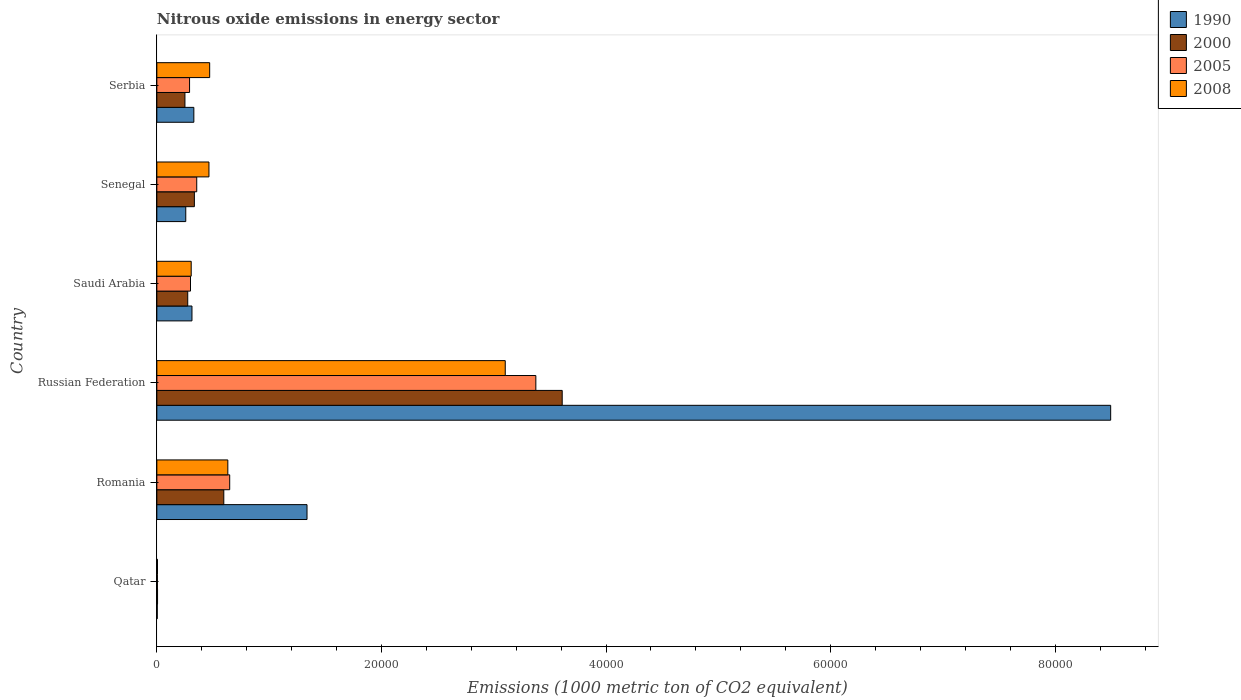How many different coloured bars are there?
Provide a succinct answer. 4. How many groups of bars are there?
Ensure brevity in your answer.  6. Are the number of bars per tick equal to the number of legend labels?
Give a very brief answer. Yes. Are the number of bars on each tick of the Y-axis equal?
Your response must be concise. Yes. How many bars are there on the 4th tick from the bottom?
Make the answer very short. 4. What is the label of the 2nd group of bars from the top?
Your answer should be compact. Senegal. In how many cases, is the number of bars for a given country not equal to the number of legend labels?
Your response must be concise. 0. What is the amount of nitrous oxide emitted in 2000 in Senegal?
Provide a succinct answer. 3341.5. Across all countries, what is the maximum amount of nitrous oxide emitted in 1990?
Keep it short and to the point. 8.49e+04. Across all countries, what is the minimum amount of nitrous oxide emitted in 1990?
Provide a succinct answer. 36. In which country was the amount of nitrous oxide emitted in 2005 maximum?
Keep it short and to the point. Russian Federation. In which country was the amount of nitrous oxide emitted in 2005 minimum?
Your answer should be compact. Qatar. What is the total amount of nitrous oxide emitted in 1990 in the graph?
Provide a succinct answer. 1.07e+05. What is the difference between the amount of nitrous oxide emitted in 2008 in Qatar and that in Romania?
Make the answer very short. -6263.5. What is the difference between the amount of nitrous oxide emitted in 2005 in Serbia and the amount of nitrous oxide emitted in 1990 in Qatar?
Offer a very short reply. 2877.8. What is the average amount of nitrous oxide emitted in 1990 per country?
Your answer should be very brief. 1.79e+04. What is the difference between the amount of nitrous oxide emitted in 2005 and amount of nitrous oxide emitted in 2000 in Romania?
Make the answer very short. 526.1. What is the ratio of the amount of nitrous oxide emitted in 2000 in Qatar to that in Serbia?
Offer a terse response. 0.02. Is the amount of nitrous oxide emitted in 2000 in Qatar less than that in Russian Federation?
Give a very brief answer. Yes. What is the difference between the highest and the second highest amount of nitrous oxide emitted in 2000?
Provide a short and direct response. 3.01e+04. What is the difference between the highest and the lowest amount of nitrous oxide emitted in 2005?
Provide a short and direct response. 3.37e+04. What does the 2nd bar from the top in Romania represents?
Provide a succinct answer. 2005. Is it the case that in every country, the sum of the amount of nitrous oxide emitted in 2000 and amount of nitrous oxide emitted in 2005 is greater than the amount of nitrous oxide emitted in 2008?
Give a very brief answer. Yes. Are all the bars in the graph horizontal?
Keep it short and to the point. Yes. How many countries are there in the graph?
Provide a succinct answer. 6. Are the values on the major ticks of X-axis written in scientific E-notation?
Your answer should be compact. No. Does the graph contain any zero values?
Give a very brief answer. No. Does the graph contain grids?
Keep it short and to the point. No. How are the legend labels stacked?
Offer a terse response. Vertical. What is the title of the graph?
Provide a succinct answer. Nitrous oxide emissions in energy sector. Does "1995" appear as one of the legend labels in the graph?
Offer a terse response. No. What is the label or title of the X-axis?
Provide a short and direct response. Emissions (1000 metric ton of CO2 equivalent). What is the Emissions (1000 metric ton of CO2 equivalent) of 2000 in Qatar?
Provide a short and direct response. 61.6. What is the Emissions (1000 metric ton of CO2 equivalent) in 2005 in Qatar?
Offer a terse response. 49.9. What is the Emissions (1000 metric ton of CO2 equivalent) of 2008 in Qatar?
Provide a short and direct response. 56.6. What is the Emissions (1000 metric ton of CO2 equivalent) of 1990 in Romania?
Keep it short and to the point. 1.34e+04. What is the Emissions (1000 metric ton of CO2 equivalent) of 2000 in Romania?
Provide a succinct answer. 5961.2. What is the Emissions (1000 metric ton of CO2 equivalent) in 2005 in Romania?
Ensure brevity in your answer.  6487.3. What is the Emissions (1000 metric ton of CO2 equivalent) in 2008 in Romania?
Offer a very short reply. 6320.1. What is the Emissions (1000 metric ton of CO2 equivalent) in 1990 in Russian Federation?
Ensure brevity in your answer.  8.49e+04. What is the Emissions (1000 metric ton of CO2 equivalent) of 2000 in Russian Federation?
Offer a terse response. 3.61e+04. What is the Emissions (1000 metric ton of CO2 equivalent) in 2005 in Russian Federation?
Give a very brief answer. 3.37e+04. What is the Emissions (1000 metric ton of CO2 equivalent) in 2008 in Russian Federation?
Your answer should be very brief. 3.10e+04. What is the Emissions (1000 metric ton of CO2 equivalent) of 1990 in Saudi Arabia?
Ensure brevity in your answer.  3126.9. What is the Emissions (1000 metric ton of CO2 equivalent) of 2000 in Saudi Arabia?
Ensure brevity in your answer.  2750.6. What is the Emissions (1000 metric ton of CO2 equivalent) of 2005 in Saudi Arabia?
Offer a very short reply. 2996.3. What is the Emissions (1000 metric ton of CO2 equivalent) of 2008 in Saudi Arabia?
Offer a very short reply. 3059.4. What is the Emissions (1000 metric ton of CO2 equivalent) of 1990 in Senegal?
Your answer should be compact. 2575.1. What is the Emissions (1000 metric ton of CO2 equivalent) in 2000 in Senegal?
Offer a very short reply. 3341.5. What is the Emissions (1000 metric ton of CO2 equivalent) of 2005 in Senegal?
Keep it short and to the point. 3551.3. What is the Emissions (1000 metric ton of CO2 equivalent) of 2008 in Senegal?
Make the answer very short. 4640.3. What is the Emissions (1000 metric ton of CO2 equivalent) in 1990 in Serbia?
Ensure brevity in your answer.  3293.8. What is the Emissions (1000 metric ton of CO2 equivalent) of 2000 in Serbia?
Provide a succinct answer. 2501.4. What is the Emissions (1000 metric ton of CO2 equivalent) in 2005 in Serbia?
Provide a short and direct response. 2913.8. What is the Emissions (1000 metric ton of CO2 equivalent) of 2008 in Serbia?
Ensure brevity in your answer.  4703.6. Across all countries, what is the maximum Emissions (1000 metric ton of CO2 equivalent) in 1990?
Offer a terse response. 8.49e+04. Across all countries, what is the maximum Emissions (1000 metric ton of CO2 equivalent) in 2000?
Provide a succinct answer. 3.61e+04. Across all countries, what is the maximum Emissions (1000 metric ton of CO2 equivalent) of 2005?
Provide a succinct answer. 3.37e+04. Across all countries, what is the maximum Emissions (1000 metric ton of CO2 equivalent) in 2008?
Keep it short and to the point. 3.10e+04. Across all countries, what is the minimum Emissions (1000 metric ton of CO2 equivalent) in 1990?
Make the answer very short. 36. Across all countries, what is the minimum Emissions (1000 metric ton of CO2 equivalent) of 2000?
Your response must be concise. 61.6. Across all countries, what is the minimum Emissions (1000 metric ton of CO2 equivalent) of 2005?
Offer a terse response. 49.9. Across all countries, what is the minimum Emissions (1000 metric ton of CO2 equivalent) of 2008?
Your response must be concise. 56.6. What is the total Emissions (1000 metric ton of CO2 equivalent) in 1990 in the graph?
Make the answer very short. 1.07e+05. What is the total Emissions (1000 metric ton of CO2 equivalent) in 2000 in the graph?
Provide a short and direct response. 5.07e+04. What is the total Emissions (1000 metric ton of CO2 equivalent) in 2005 in the graph?
Your response must be concise. 4.97e+04. What is the total Emissions (1000 metric ton of CO2 equivalent) of 2008 in the graph?
Provide a short and direct response. 4.98e+04. What is the difference between the Emissions (1000 metric ton of CO2 equivalent) in 1990 in Qatar and that in Romania?
Offer a very short reply. -1.33e+04. What is the difference between the Emissions (1000 metric ton of CO2 equivalent) of 2000 in Qatar and that in Romania?
Your answer should be compact. -5899.6. What is the difference between the Emissions (1000 metric ton of CO2 equivalent) in 2005 in Qatar and that in Romania?
Ensure brevity in your answer.  -6437.4. What is the difference between the Emissions (1000 metric ton of CO2 equivalent) in 2008 in Qatar and that in Romania?
Ensure brevity in your answer.  -6263.5. What is the difference between the Emissions (1000 metric ton of CO2 equivalent) of 1990 in Qatar and that in Russian Federation?
Make the answer very short. -8.49e+04. What is the difference between the Emissions (1000 metric ton of CO2 equivalent) in 2000 in Qatar and that in Russian Federation?
Keep it short and to the point. -3.60e+04. What is the difference between the Emissions (1000 metric ton of CO2 equivalent) of 2005 in Qatar and that in Russian Federation?
Give a very brief answer. -3.37e+04. What is the difference between the Emissions (1000 metric ton of CO2 equivalent) in 2008 in Qatar and that in Russian Federation?
Provide a succinct answer. -3.10e+04. What is the difference between the Emissions (1000 metric ton of CO2 equivalent) in 1990 in Qatar and that in Saudi Arabia?
Your answer should be compact. -3090.9. What is the difference between the Emissions (1000 metric ton of CO2 equivalent) in 2000 in Qatar and that in Saudi Arabia?
Offer a very short reply. -2689. What is the difference between the Emissions (1000 metric ton of CO2 equivalent) of 2005 in Qatar and that in Saudi Arabia?
Give a very brief answer. -2946.4. What is the difference between the Emissions (1000 metric ton of CO2 equivalent) in 2008 in Qatar and that in Saudi Arabia?
Provide a succinct answer. -3002.8. What is the difference between the Emissions (1000 metric ton of CO2 equivalent) of 1990 in Qatar and that in Senegal?
Keep it short and to the point. -2539.1. What is the difference between the Emissions (1000 metric ton of CO2 equivalent) of 2000 in Qatar and that in Senegal?
Provide a short and direct response. -3279.9. What is the difference between the Emissions (1000 metric ton of CO2 equivalent) in 2005 in Qatar and that in Senegal?
Give a very brief answer. -3501.4. What is the difference between the Emissions (1000 metric ton of CO2 equivalent) of 2008 in Qatar and that in Senegal?
Your response must be concise. -4583.7. What is the difference between the Emissions (1000 metric ton of CO2 equivalent) in 1990 in Qatar and that in Serbia?
Provide a succinct answer. -3257.8. What is the difference between the Emissions (1000 metric ton of CO2 equivalent) of 2000 in Qatar and that in Serbia?
Your answer should be compact. -2439.8. What is the difference between the Emissions (1000 metric ton of CO2 equivalent) of 2005 in Qatar and that in Serbia?
Your answer should be very brief. -2863.9. What is the difference between the Emissions (1000 metric ton of CO2 equivalent) in 2008 in Qatar and that in Serbia?
Your answer should be compact. -4647. What is the difference between the Emissions (1000 metric ton of CO2 equivalent) of 1990 in Romania and that in Russian Federation?
Give a very brief answer. -7.16e+04. What is the difference between the Emissions (1000 metric ton of CO2 equivalent) in 2000 in Romania and that in Russian Federation?
Your answer should be very brief. -3.01e+04. What is the difference between the Emissions (1000 metric ton of CO2 equivalent) in 2005 in Romania and that in Russian Federation?
Provide a short and direct response. -2.73e+04. What is the difference between the Emissions (1000 metric ton of CO2 equivalent) of 2008 in Romania and that in Russian Federation?
Your answer should be very brief. -2.47e+04. What is the difference between the Emissions (1000 metric ton of CO2 equivalent) of 1990 in Romania and that in Saudi Arabia?
Offer a terse response. 1.02e+04. What is the difference between the Emissions (1000 metric ton of CO2 equivalent) of 2000 in Romania and that in Saudi Arabia?
Make the answer very short. 3210.6. What is the difference between the Emissions (1000 metric ton of CO2 equivalent) in 2005 in Romania and that in Saudi Arabia?
Ensure brevity in your answer.  3491. What is the difference between the Emissions (1000 metric ton of CO2 equivalent) of 2008 in Romania and that in Saudi Arabia?
Make the answer very short. 3260.7. What is the difference between the Emissions (1000 metric ton of CO2 equivalent) in 1990 in Romania and that in Senegal?
Offer a terse response. 1.08e+04. What is the difference between the Emissions (1000 metric ton of CO2 equivalent) of 2000 in Romania and that in Senegal?
Offer a terse response. 2619.7. What is the difference between the Emissions (1000 metric ton of CO2 equivalent) in 2005 in Romania and that in Senegal?
Keep it short and to the point. 2936. What is the difference between the Emissions (1000 metric ton of CO2 equivalent) in 2008 in Romania and that in Senegal?
Provide a short and direct response. 1679.8. What is the difference between the Emissions (1000 metric ton of CO2 equivalent) of 1990 in Romania and that in Serbia?
Offer a very short reply. 1.01e+04. What is the difference between the Emissions (1000 metric ton of CO2 equivalent) of 2000 in Romania and that in Serbia?
Keep it short and to the point. 3459.8. What is the difference between the Emissions (1000 metric ton of CO2 equivalent) in 2005 in Romania and that in Serbia?
Provide a short and direct response. 3573.5. What is the difference between the Emissions (1000 metric ton of CO2 equivalent) in 2008 in Romania and that in Serbia?
Provide a succinct answer. 1616.5. What is the difference between the Emissions (1000 metric ton of CO2 equivalent) in 1990 in Russian Federation and that in Saudi Arabia?
Give a very brief answer. 8.18e+04. What is the difference between the Emissions (1000 metric ton of CO2 equivalent) of 2000 in Russian Federation and that in Saudi Arabia?
Provide a short and direct response. 3.33e+04. What is the difference between the Emissions (1000 metric ton of CO2 equivalent) of 2005 in Russian Federation and that in Saudi Arabia?
Provide a short and direct response. 3.08e+04. What is the difference between the Emissions (1000 metric ton of CO2 equivalent) in 2008 in Russian Federation and that in Saudi Arabia?
Offer a very short reply. 2.80e+04. What is the difference between the Emissions (1000 metric ton of CO2 equivalent) in 1990 in Russian Federation and that in Senegal?
Provide a short and direct response. 8.24e+04. What is the difference between the Emissions (1000 metric ton of CO2 equivalent) in 2000 in Russian Federation and that in Senegal?
Give a very brief answer. 3.28e+04. What is the difference between the Emissions (1000 metric ton of CO2 equivalent) of 2005 in Russian Federation and that in Senegal?
Your answer should be compact. 3.02e+04. What is the difference between the Emissions (1000 metric ton of CO2 equivalent) in 2008 in Russian Federation and that in Senegal?
Give a very brief answer. 2.64e+04. What is the difference between the Emissions (1000 metric ton of CO2 equivalent) of 1990 in Russian Federation and that in Serbia?
Your response must be concise. 8.16e+04. What is the difference between the Emissions (1000 metric ton of CO2 equivalent) in 2000 in Russian Federation and that in Serbia?
Ensure brevity in your answer.  3.36e+04. What is the difference between the Emissions (1000 metric ton of CO2 equivalent) of 2005 in Russian Federation and that in Serbia?
Ensure brevity in your answer.  3.08e+04. What is the difference between the Emissions (1000 metric ton of CO2 equivalent) of 2008 in Russian Federation and that in Serbia?
Keep it short and to the point. 2.63e+04. What is the difference between the Emissions (1000 metric ton of CO2 equivalent) in 1990 in Saudi Arabia and that in Senegal?
Keep it short and to the point. 551.8. What is the difference between the Emissions (1000 metric ton of CO2 equivalent) of 2000 in Saudi Arabia and that in Senegal?
Give a very brief answer. -590.9. What is the difference between the Emissions (1000 metric ton of CO2 equivalent) of 2005 in Saudi Arabia and that in Senegal?
Offer a very short reply. -555. What is the difference between the Emissions (1000 metric ton of CO2 equivalent) of 2008 in Saudi Arabia and that in Senegal?
Give a very brief answer. -1580.9. What is the difference between the Emissions (1000 metric ton of CO2 equivalent) in 1990 in Saudi Arabia and that in Serbia?
Your answer should be compact. -166.9. What is the difference between the Emissions (1000 metric ton of CO2 equivalent) of 2000 in Saudi Arabia and that in Serbia?
Provide a short and direct response. 249.2. What is the difference between the Emissions (1000 metric ton of CO2 equivalent) in 2005 in Saudi Arabia and that in Serbia?
Your response must be concise. 82.5. What is the difference between the Emissions (1000 metric ton of CO2 equivalent) of 2008 in Saudi Arabia and that in Serbia?
Give a very brief answer. -1644.2. What is the difference between the Emissions (1000 metric ton of CO2 equivalent) in 1990 in Senegal and that in Serbia?
Ensure brevity in your answer.  -718.7. What is the difference between the Emissions (1000 metric ton of CO2 equivalent) of 2000 in Senegal and that in Serbia?
Offer a terse response. 840.1. What is the difference between the Emissions (1000 metric ton of CO2 equivalent) of 2005 in Senegal and that in Serbia?
Give a very brief answer. 637.5. What is the difference between the Emissions (1000 metric ton of CO2 equivalent) in 2008 in Senegal and that in Serbia?
Your answer should be very brief. -63.3. What is the difference between the Emissions (1000 metric ton of CO2 equivalent) in 1990 in Qatar and the Emissions (1000 metric ton of CO2 equivalent) in 2000 in Romania?
Your answer should be compact. -5925.2. What is the difference between the Emissions (1000 metric ton of CO2 equivalent) in 1990 in Qatar and the Emissions (1000 metric ton of CO2 equivalent) in 2005 in Romania?
Ensure brevity in your answer.  -6451.3. What is the difference between the Emissions (1000 metric ton of CO2 equivalent) of 1990 in Qatar and the Emissions (1000 metric ton of CO2 equivalent) of 2008 in Romania?
Offer a terse response. -6284.1. What is the difference between the Emissions (1000 metric ton of CO2 equivalent) in 2000 in Qatar and the Emissions (1000 metric ton of CO2 equivalent) in 2005 in Romania?
Your response must be concise. -6425.7. What is the difference between the Emissions (1000 metric ton of CO2 equivalent) in 2000 in Qatar and the Emissions (1000 metric ton of CO2 equivalent) in 2008 in Romania?
Keep it short and to the point. -6258.5. What is the difference between the Emissions (1000 metric ton of CO2 equivalent) of 2005 in Qatar and the Emissions (1000 metric ton of CO2 equivalent) of 2008 in Romania?
Ensure brevity in your answer.  -6270.2. What is the difference between the Emissions (1000 metric ton of CO2 equivalent) in 1990 in Qatar and the Emissions (1000 metric ton of CO2 equivalent) in 2000 in Russian Federation?
Offer a very short reply. -3.61e+04. What is the difference between the Emissions (1000 metric ton of CO2 equivalent) of 1990 in Qatar and the Emissions (1000 metric ton of CO2 equivalent) of 2005 in Russian Federation?
Give a very brief answer. -3.37e+04. What is the difference between the Emissions (1000 metric ton of CO2 equivalent) of 1990 in Qatar and the Emissions (1000 metric ton of CO2 equivalent) of 2008 in Russian Federation?
Keep it short and to the point. -3.10e+04. What is the difference between the Emissions (1000 metric ton of CO2 equivalent) of 2000 in Qatar and the Emissions (1000 metric ton of CO2 equivalent) of 2005 in Russian Federation?
Offer a very short reply. -3.37e+04. What is the difference between the Emissions (1000 metric ton of CO2 equivalent) in 2000 in Qatar and the Emissions (1000 metric ton of CO2 equivalent) in 2008 in Russian Federation?
Provide a succinct answer. -3.10e+04. What is the difference between the Emissions (1000 metric ton of CO2 equivalent) of 2005 in Qatar and the Emissions (1000 metric ton of CO2 equivalent) of 2008 in Russian Federation?
Make the answer very short. -3.10e+04. What is the difference between the Emissions (1000 metric ton of CO2 equivalent) of 1990 in Qatar and the Emissions (1000 metric ton of CO2 equivalent) of 2000 in Saudi Arabia?
Your response must be concise. -2714.6. What is the difference between the Emissions (1000 metric ton of CO2 equivalent) in 1990 in Qatar and the Emissions (1000 metric ton of CO2 equivalent) in 2005 in Saudi Arabia?
Provide a short and direct response. -2960.3. What is the difference between the Emissions (1000 metric ton of CO2 equivalent) of 1990 in Qatar and the Emissions (1000 metric ton of CO2 equivalent) of 2008 in Saudi Arabia?
Offer a terse response. -3023.4. What is the difference between the Emissions (1000 metric ton of CO2 equivalent) in 2000 in Qatar and the Emissions (1000 metric ton of CO2 equivalent) in 2005 in Saudi Arabia?
Your answer should be very brief. -2934.7. What is the difference between the Emissions (1000 metric ton of CO2 equivalent) in 2000 in Qatar and the Emissions (1000 metric ton of CO2 equivalent) in 2008 in Saudi Arabia?
Give a very brief answer. -2997.8. What is the difference between the Emissions (1000 metric ton of CO2 equivalent) of 2005 in Qatar and the Emissions (1000 metric ton of CO2 equivalent) of 2008 in Saudi Arabia?
Your answer should be compact. -3009.5. What is the difference between the Emissions (1000 metric ton of CO2 equivalent) in 1990 in Qatar and the Emissions (1000 metric ton of CO2 equivalent) in 2000 in Senegal?
Keep it short and to the point. -3305.5. What is the difference between the Emissions (1000 metric ton of CO2 equivalent) of 1990 in Qatar and the Emissions (1000 metric ton of CO2 equivalent) of 2005 in Senegal?
Make the answer very short. -3515.3. What is the difference between the Emissions (1000 metric ton of CO2 equivalent) in 1990 in Qatar and the Emissions (1000 metric ton of CO2 equivalent) in 2008 in Senegal?
Your answer should be compact. -4604.3. What is the difference between the Emissions (1000 metric ton of CO2 equivalent) of 2000 in Qatar and the Emissions (1000 metric ton of CO2 equivalent) of 2005 in Senegal?
Your answer should be compact. -3489.7. What is the difference between the Emissions (1000 metric ton of CO2 equivalent) in 2000 in Qatar and the Emissions (1000 metric ton of CO2 equivalent) in 2008 in Senegal?
Your answer should be compact. -4578.7. What is the difference between the Emissions (1000 metric ton of CO2 equivalent) in 2005 in Qatar and the Emissions (1000 metric ton of CO2 equivalent) in 2008 in Senegal?
Your response must be concise. -4590.4. What is the difference between the Emissions (1000 metric ton of CO2 equivalent) of 1990 in Qatar and the Emissions (1000 metric ton of CO2 equivalent) of 2000 in Serbia?
Ensure brevity in your answer.  -2465.4. What is the difference between the Emissions (1000 metric ton of CO2 equivalent) of 1990 in Qatar and the Emissions (1000 metric ton of CO2 equivalent) of 2005 in Serbia?
Keep it short and to the point. -2877.8. What is the difference between the Emissions (1000 metric ton of CO2 equivalent) of 1990 in Qatar and the Emissions (1000 metric ton of CO2 equivalent) of 2008 in Serbia?
Give a very brief answer. -4667.6. What is the difference between the Emissions (1000 metric ton of CO2 equivalent) of 2000 in Qatar and the Emissions (1000 metric ton of CO2 equivalent) of 2005 in Serbia?
Your answer should be very brief. -2852.2. What is the difference between the Emissions (1000 metric ton of CO2 equivalent) in 2000 in Qatar and the Emissions (1000 metric ton of CO2 equivalent) in 2008 in Serbia?
Provide a succinct answer. -4642. What is the difference between the Emissions (1000 metric ton of CO2 equivalent) of 2005 in Qatar and the Emissions (1000 metric ton of CO2 equivalent) of 2008 in Serbia?
Your answer should be very brief. -4653.7. What is the difference between the Emissions (1000 metric ton of CO2 equivalent) in 1990 in Romania and the Emissions (1000 metric ton of CO2 equivalent) in 2000 in Russian Federation?
Provide a short and direct response. -2.27e+04. What is the difference between the Emissions (1000 metric ton of CO2 equivalent) in 1990 in Romania and the Emissions (1000 metric ton of CO2 equivalent) in 2005 in Russian Federation?
Offer a very short reply. -2.04e+04. What is the difference between the Emissions (1000 metric ton of CO2 equivalent) in 1990 in Romania and the Emissions (1000 metric ton of CO2 equivalent) in 2008 in Russian Federation?
Offer a very short reply. -1.77e+04. What is the difference between the Emissions (1000 metric ton of CO2 equivalent) of 2000 in Romania and the Emissions (1000 metric ton of CO2 equivalent) of 2005 in Russian Federation?
Offer a terse response. -2.78e+04. What is the difference between the Emissions (1000 metric ton of CO2 equivalent) in 2000 in Romania and the Emissions (1000 metric ton of CO2 equivalent) in 2008 in Russian Federation?
Ensure brevity in your answer.  -2.51e+04. What is the difference between the Emissions (1000 metric ton of CO2 equivalent) in 2005 in Romania and the Emissions (1000 metric ton of CO2 equivalent) in 2008 in Russian Federation?
Your answer should be very brief. -2.45e+04. What is the difference between the Emissions (1000 metric ton of CO2 equivalent) of 1990 in Romania and the Emissions (1000 metric ton of CO2 equivalent) of 2000 in Saudi Arabia?
Make the answer very short. 1.06e+04. What is the difference between the Emissions (1000 metric ton of CO2 equivalent) of 1990 in Romania and the Emissions (1000 metric ton of CO2 equivalent) of 2005 in Saudi Arabia?
Your response must be concise. 1.04e+04. What is the difference between the Emissions (1000 metric ton of CO2 equivalent) in 1990 in Romania and the Emissions (1000 metric ton of CO2 equivalent) in 2008 in Saudi Arabia?
Offer a very short reply. 1.03e+04. What is the difference between the Emissions (1000 metric ton of CO2 equivalent) of 2000 in Romania and the Emissions (1000 metric ton of CO2 equivalent) of 2005 in Saudi Arabia?
Offer a very short reply. 2964.9. What is the difference between the Emissions (1000 metric ton of CO2 equivalent) of 2000 in Romania and the Emissions (1000 metric ton of CO2 equivalent) of 2008 in Saudi Arabia?
Provide a short and direct response. 2901.8. What is the difference between the Emissions (1000 metric ton of CO2 equivalent) of 2005 in Romania and the Emissions (1000 metric ton of CO2 equivalent) of 2008 in Saudi Arabia?
Ensure brevity in your answer.  3427.9. What is the difference between the Emissions (1000 metric ton of CO2 equivalent) in 1990 in Romania and the Emissions (1000 metric ton of CO2 equivalent) in 2000 in Senegal?
Your answer should be very brief. 1.00e+04. What is the difference between the Emissions (1000 metric ton of CO2 equivalent) in 1990 in Romania and the Emissions (1000 metric ton of CO2 equivalent) in 2005 in Senegal?
Your answer should be compact. 9821. What is the difference between the Emissions (1000 metric ton of CO2 equivalent) of 1990 in Romania and the Emissions (1000 metric ton of CO2 equivalent) of 2008 in Senegal?
Give a very brief answer. 8732. What is the difference between the Emissions (1000 metric ton of CO2 equivalent) in 2000 in Romania and the Emissions (1000 metric ton of CO2 equivalent) in 2005 in Senegal?
Offer a terse response. 2409.9. What is the difference between the Emissions (1000 metric ton of CO2 equivalent) in 2000 in Romania and the Emissions (1000 metric ton of CO2 equivalent) in 2008 in Senegal?
Provide a succinct answer. 1320.9. What is the difference between the Emissions (1000 metric ton of CO2 equivalent) in 2005 in Romania and the Emissions (1000 metric ton of CO2 equivalent) in 2008 in Senegal?
Keep it short and to the point. 1847. What is the difference between the Emissions (1000 metric ton of CO2 equivalent) of 1990 in Romania and the Emissions (1000 metric ton of CO2 equivalent) of 2000 in Serbia?
Ensure brevity in your answer.  1.09e+04. What is the difference between the Emissions (1000 metric ton of CO2 equivalent) in 1990 in Romania and the Emissions (1000 metric ton of CO2 equivalent) in 2005 in Serbia?
Keep it short and to the point. 1.05e+04. What is the difference between the Emissions (1000 metric ton of CO2 equivalent) of 1990 in Romania and the Emissions (1000 metric ton of CO2 equivalent) of 2008 in Serbia?
Offer a very short reply. 8668.7. What is the difference between the Emissions (1000 metric ton of CO2 equivalent) in 2000 in Romania and the Emissions (1000 metric ton of CO2 equivalent) in 2005 in Serbia?
Offer a terse response. 3047.4. What is the difference between the Emissions (1000 metric ton of CO2 equivalent) in 2000 in Romania and the Emissions (1000 metric ton of CO2 equivalent) in 2008 in Serbia?
Provide a succinct answer. 1257.6. What is the difference between the Emissions (1000 metric ton of CO2 equivalent) of 2005 in Romania and the Emissions (1000 metric ton of CO2 equivalent) of 2008 in Serbia?
Offer a very short reply. 1783.7. What is the difference between the Emissions (1000 metric ton of CO2 equivalent) of 1990 in Russian Federation and the Emissions (1000 metric ton of CO2 equivalent) of 2000 in Saudi Arabia?
Offer a terse response. 8.22e+04. What is the difference between the Emissions (1000 metric ton of CO2 equivalent) of 1990 in Russian Federation and the Emissions (1000 metric ton of CO2 equivalent) of 2005 in Saudi Arabia?
Offer a very short reply. 8.19e+04. What is the difference between the Emissions (1000 metric ton of CO2 equivalent) of 1990 in Russian Federation and the Emissions (1000 metric ton of CO2 equivalent) of 2008 in Saudi Arabia?
Offer a very short reply. 8.19e+04. What is the difference between the Emissions (1000 metric ton of CO2 equivalent) in 2000 in Russian Federation and the Emissions (1000 metric ton of CO2 equivalent) in 2005 in Saudi Arabia?
Ensure brevity in your answer.  3.31e+04. What is the difference between the Emissions (1000 metric ton of CO2 equivalent) of 2000 in Russian Federation and the Emissions (1000 metric ton of CO2 equivalent) of 2008 in Saudi Arabia?
Your answer should be compact. 3.30e+04. What is the difference between the Emissions (1000 metric ton of CO2 equivalent) of 2005 in Russian Federation and the Emissions (1000 metric ton of CO2 equivalent) of 2008 in Saudi Arabia?
Offer a terse response. 3.07e+04. What is the difference between the Emissions (1000 metric ton of CO2 equivalent) of 1990 in Russian Federation and the Emissions (1000 metric ton of CO2 equivalent) of 2000 in Senegal?
Offer a very short reply. 8.16e+04. What is the difference between the Emissions (1000 metric ton of CO2 equivalent) in 1990 in Russian Federation and the Emissions (1000 metric ton of CO2 equivalent) in 2005 in Senegal?
Provide a succinct answer. 8.14e+04. What is the difference between the Emissions (1000 metric ton of CO2 equivalent) of 1990 in Russian Federation and the Emissions (1000 metric ton of CO2 equivalent) of 2008 in Senegal?
Offer a very short reply. 8.03e+04. What is the difference between the Emissions (1000 metric ton of CO2 equivalent) in 2000 in Russian Federation and the Emissions (1000 metric ton of CO2 equivalent) in 2005 in Senegal?
Make the answer very short. 3.25e+04. What is the difference between the Emissions (1000 metric ton of CO2 equivalent) in 2000 in Russian Federation and the Emissions (1000 metric ton of CO2 equivalent) in 2008 in Senegal?
Keep it short and to the point. 3.15e+04. What is the difference between the Emissions (1000 metric ton of CO2 equivalent) of 2005 in Russian Federation and the Emissions (1000 metric ton of CO2 equivalent) of 2008 in Senegal?
Give a very brief answer. 2.91e+04. What is the difference between the Emissions (1000 metric ton of CO2 equivalent) of 1990 in Russian Federation and the Emissions (1000 metric ton of CO2 equivalent) of 2000 in Serbia?
Keep it short and to the point. 8.24e+04. What is the difference between the Emissions (1000 metric ton of CO2 equivalent) in 1990 in Russian Federation and the Emissions (1000 metric ton of CO2 equivalent) in 2005 in Serbia?
Provide a succinct answer. 8.20e+04. What is the difference between the Emissions (1000 metric ton of CO2 equivalent) in 1990 in Russian Federation and the Emissions (1000 metric ton of CO2 equivalent) in 2008 in Serbia?
Offer a very short reply. 8.02e+04. What is the difference between the Emissions (1000 metric ton of CO2 equivalent) of 2000 in Russian Federation and the Emissions (1000 metric ton of CO2 equivalent) of 2005 in Serbia?
Keep it short and to the point. 3.32e+04. What is the difference between the Emissions (1000 metric ton of CO2 equivalent) in 2000 in Russian Federation and the Emissions (1000 metric ton of CO2 equivalent) in 2008 in Serbia?
Make the answer very short. 3.14e+04. What is the difference between the Emissions (1000 metric ton of CO2 equivalent) in 2005 in Russian Federation and the Emissions (1000 metric ton of CO2 equivalent) in 2008 in Serbia?
Provide a succinct answer. 2.90e+04. What is the difference between the Emissions (1000 metric ton of CO2 equivalent) of 1990 in Saudi Arabia and the Emissions (1000 metric ton of CO2 equivalent) of 2000 in Senegal?
Your answer should be very brief. -214.6. What is the difference between the Emissions (1000 metric ton of CO2 equivalent) in 1990 in Saudi Arabia and the Emissions (1000 metric ton of CO2 equivalent) in 2005 in Senegal?
Ensure brevity in your answer.  -424.4. What is the difference between the Emissions (1000 metric ton of CO2 equivalent) of 1990 in Saudi Arabia and the Emissions (1000 metric ton of CO2 equivalent) of 2008 in Senegal?
Offer a terse response. -1513.4. What is the difference between the Emissions (1000 metric ton of CO2 equivalent) of 2000 in Saudi Arabia and the Emissions (1000 metric ton of CO2 equivalent) of 2005 in Senegal?
Your response must be concise. -800.7. What is the difference between the Emissions (1000 metric ton of CO2 equivalent) of 2000 in Saudi Arabia and the Emissions (1000 metric ton of CO2 equivalent) of 2008 in Senegal?
Your answer should be very brief. -1889.7. What is the difference between the Emissions (1000 metric ton of CO2 equivalent) in 2005 in Saudi Arabia and the Emissions (1000 metric ton of CO2 equivalent) in 2008 in Senegal?
Your answer should be very brief. -1644. What is the difference between the Emissions (1000 metric ton of CO2 equivalent) of 1990 in Saudi Arabia and the Emissions (1000 metric ton of CO2 equivalent) of 2000 in Serbia?
Keep it short and to the point. 625.5. What is the difference between the Emissions (1000 metric ton of CO2 equivalent) in 1990 in Saudi Arabia and the Emissions (1000 metric ton of CO2 equivalent) in 2005 in Serbia?
Make the answer very short. 213.1. What is the difference between the Emissions (1000 metric ton of CO2 equivalent) of 1990 in Saudi Arabia and the Emissions (1000 metric ton of CO2 equivalent) of 2008 in Serbia?
Your answer should be very brief. -1576.7. What is the difference between the Emissions (1000 metric ton of CO2 equivalent) in 2000 in Saudi Arabia and the Emissions (1000 metric ton of CO2 equivalent) in 2005 in Serbia?
Make the answer very short. -163.2. What is the difference between the Emissions (1000 metric ton of CO2 equivalent) in 2000 in Saudi Arabia and the Emissions (1000 metric ton of CO2 equivalent) in 2008 in Serbia?
Offer a very short reply. -1953. What is the difference between the Emissions (1000 metric ton of CO2 equivalent) of 2005 in Saudi Arabia and the Emissions (1000 metric ton of CO2 equivalent) of 2008 in Serbia?
Keep it short and to the point. -1707.3. What is the difference between the Emissions (1000 metric ton of CO2 equivalent) of 1990 in Senegal and the Emissions (1000 metric ton of CO2 equivalent) of 2000 in Serbia?
Provide a short and direct response. 73.7. What is the difference between the Emissions (1000 metric ton of CO2 equivalent) in 1990 in Senegal and the Emissions (1000 metric ton of CO2 equivalent) in 2005 in Serbia?
Give a very brief answer. -338.7. What is the difference between the Emissions (1000 metric ton of CO2 equivalent) of 1990 in Senegal and the Emissions (1000 metric ton of CO2 equivalent) of 2008 in Serbia?
Make the answer very short. -2128.5. What is the difference between the Emissions (1000 metric ton of CO2 equivalent) in 2000 in Senegal and the Emissions (1000 metric ton of CO2 equivalent) in 2005 in Serbia?
Provide a short and direct response. 427.7. What is the difference between the Emissions (1000 metric ton of CO2 equivalent) in 2000 in Senegal and the Emissions (1000 metric ton of CO2 equivalent) in 2008 in Serbia?
Make the answer very short. -1362.1. What is the difference between the Emissions (1000 metric ton of CO2 equivalent) in 2005 in Senegal and the Emissions (1000 metric ton of CO2 equivalent) in 2008 in Serbia?
Keep it short and to the point. -1152.3. What is the average Emissions (1000 metric ton of CO2 equivalent) in 1990 per country?
Offer a terse response. 1.79e+04. What is the average Emissions (1000 metric ton of CO2 equivalent) in 2000 per country?
Your answer should be very brief. 8452.08. What is the average Emissions (1000 metric ton of CO2 equivalent) of 2005 per country?
Keep it short and to the point. 8291.27. What is the average Emissions (1000 metric ton of CO2 equivalent) in 2008 per country?
Ensure brevity in your answer.  8300.63. What is the difference between the Emissions (1000 metric ton of CO2 equivalent) of 1990 and Emissions (1000 metric ton of CO2 equivalent) of 2000 in Qatar?
Offer a terse response. -25.6. What is the difference between the Emissions (1000 metric ton of CO2 equivalent) of 1990 and Emissions (1000 metric ton of CO2 equivalent) of 2005 in Qatar?
Keep it short and to the point. -13.9. What is the difference between the Emissions (1000 metric ton of CO2 equivalent) of 1990 and Emissions (1000 metric ton of CO2 equivalent) of 2008 in Qatar?
Provide a short and direct response. -20.6. What is the difference between the Emissions (1000 metric ton of CO2 equivalent) of 2000 and Emissions (1000 metric ton of CO2 equivalent) of 2005 in Qatar?
Provide a short and direct response. 11.7. What is the difference between the Emissions (1000 metric ton of CO2 equivalent) of 2005 and Emissions (1000 metric ton of CO2 equivalent) of 2008 in Qatar?
Your response must be concise. -6.7. What is the difference between the Emissions (1000 metric ton of CO2 equivalent) of 1990 and Emissions (1000 metric ton of CO2 equivalent) of 2000 in Romania?
Your answer should be compact. 7411.1. What is the difference between the Emissions (1000 metric ton of CO2 equivalent) in 1990 and Emissions (1000 metric ton of CO2 equivalent) in 2005 in Romania?
Your answer should be very brief. 6885. What is the difference between the Emissions (1000 metric ton of CO2 equivalent) in 1990 and Emissions (1000 metric ton of CO2 equivalent) in 2008 in Romania?
Make the answer very short. 7052.2. What is the difference between the Emissions (1000 metric ton of CO2 equivalent) in 2000 and Emissions (1000 metric ton of CO2 equivalent) in 2005 in Romania?
Your answer should be compact. -526.1. What is the difference between the Emissions (1000 metric ton of CO2 equivalent) of 2000 and Emissions (1000 metric ton of CO2 equivalent) of 2008 in Romania?
Ensure brevity in your answer.  -358.9. What is the difference between the Emissions (1000 metric ton of CO2 equivalent) in 2005 and Emissions (1000 metric ton of CO2 equivalent) in 2008 in Romania?
Offer a very short reply. 167.2. What is the difference between the Emissions (1000 metric ton of CO2 equivalent) in 1990 and Emissions (1000 metric ton of CO2 equivalent) in 2000 in Russian Federation?
Keep it short and to the point. 4.88e+04. What is the difference between the Emissions (1000 metric ton of CO2 equivalent) in 1990 and Emissions (1000 metric ton of CO2 equivalent) in 2005 in Russian Federation?
Offer a terse response. 5.12e+04. What is the difference between the Emissions (1000 metric ton of CO2 equivalent) in 1990 and Emissions (1000 metric ton of CO2 equivalent) in 2008 in Russian Federation?
Ensure brevity in your answer.  5.39e+04. What is the difference between the Emissions (1000 metric ton of CO2 equivalent) in 2000 and Emissions (1000 metric ton of CO2 equivalent) in 2005 in Russian Federation?
Your response must be concise. 2347.2. What is the difference between the Emissions (1000 metric ton of CO2 equivalent) of 2000 and Emissions (1000 metric ton of CO2 equivalent) of 2008 in Russian Federation?
Offer a very short reply. 5072.4. What is the difference between the Emissions (1000 metric ton of CO2 equivalent) of 2005 and Emissions (1000 metric ton of CO2 equivalent) of 2008 in Russian Federation?
Make the answer very short. 2725.2. What is the difference between the Emissions (1000 metric ton of CO2 equivalent) of 1990 and Emissions (1000 metric ton of CO2 equivalent) of 2000 in Saudi Arabia?
Give a very brief answer. 376.3. What is the difference between the Emissions (1000 metric ton of CO2 equivalent) in 1990 and Emissions (1000 metric ton of CO2 equivalent) in 2005 in Saudi Arabia?
Your answer should be compact. 130.6. What is the difference between the Emissions (1000 metric ton of CO2 equivalent) in 1990 and Emissions (1000 metric ton of CO2 equivalent) in 2008 in Saudi Arabia?
Offer a very short reply. 67.5. What is the difference between the Emissions (1000 metric ton of CO2 equivalent) in 2000 and Emissions (1000 metric ton of CO2 equivalent) in 2005 in Saudi Arabia?
Your response must be concise. -245.7. What is the difference between the Emissions (1000 metric ton of CO2 equivalent) in 2000 and Emissions (1000 metric ton of CO2 equivalent) in 2008 in Saudi Arabia?
Make the answer very short. -308.8. What is the difference between the Emissions (1000 metric ton of CO2 equivalent) of 2005 and Emissions (1000 metric ton of CO2 equivalent) of 2008 in Saudi Arabia?
Keep it short and to the point. -63.1. What is the difference between the Emissions (1000 metric ton of CO2 equivalent) in 1990 and Emissions (1000 metric ton of CO2 equivalent) in 2000 in Senegal?
Provide a short and direct response. -766.4. What is the difference between the Emissions (1000 metric ton of CO2 equivalent) in 1990 and Emissions (1000 metric ton of CO2 equivalent) in 2005 in Senegal?
Provide a short and direct response. -976.2. What is the difference between the Emissions (1000 metric ton of CO2 equivalent) of 1990 and Emissions (1000 metric ton of CO2 equivalent) of 2008 in Senegal?
Your answer should be compact. -2065.2. What is the difference between the Emissions (1000 metric ton of CO2 equivalent) in 2000 and Emissions (1000 metric ton of CO2 equivalent) in 2005 in Senegal?
Provide a short and direct response. -209.8. What is the difference between the Emissions (1000 metric ton of CO2 equivalent) in 2000 and Emissions (1000 metric ton of CO2 equivalent) in 2008 in Senegal?
Your answer should be compact. -1298.8. What is the difference between the Emissions (1000 metric ton of CO2 equivalent) of 2005 and Emissions (1000 metric ton of CO2 equivalent) of 2008 in Senegal?
Provide a succinct answer. -1089. What is the difference between the Emissions (1000 metric ton of CO2 equivalent) in 1990 and Emissions (1000 metric ton of CO2 equivalent) in 2000 in Serbia?
Provide a succinct answer. 792.4. What is the difference between the Emissions (1000 metric ton of CO2 equivalent) of 1990 and Emissions (1000 metric ton of CO2 equivalent) of 2005 in Serbia?
Provide a short and direct response. 380. What is the difference between the Emissions (1000 metric ton of CO2 equivalent) in 1990 and Emissions (1000 metric ton of CO2 equivalent) in 2008 in Serbia?
Ensure brevity in your answer.  -1409.8. What is the difference between the Emissions (1000 metric ton of CO2 equivalent) in 2000 and Emissions (1000 metric ton of CO2 equivalent) in 2005 in Serbia?
Give a very brief answer. -412.4. What is the difference between the Emissions (1000 metric ton of CO2 equivalent) in 2000 and Emissions (1000 metric ton of CO2 equivalent) in 2008 in Serbia?
Your answer should be compact. -2202.2. What is the difference between the Emissions (1000 metric ton of CO2 equivalent) of 2005 and Emissions (1000 metric ton of CO2 equivalent) of 2008 in Serbia?
Offer a very short reply. -1789.8. What is the ratio of the Emissions (1000 metric ton of CO2 equivalent) of 1990 in Qatar to that in Romania?
Your response must be concise. 0. What is the ratio of the Emissions (1000 metric ton of CO2 equivalent) of 2000 in Qatar to that in Romania?
Give a very brief answer. 0.01. What is the ratio of the Emissions (1000 metric ton of CO2 equivalent) of 2005 in Qatar to that in Romania?
Make the answer very short. 0.01. What is the ratio of the Emissions (1000 metric ton of CO2 equivalent) in 2008 in Qatar to that in Romania?
Provide a short and direct response. 0.01. What is the ratio of the Emissions (1000 metric ton of CO2 equivalent) of 2000 in Qatar to that in Russian Federation?
Provide a succinct answer. 0. What is the ratio of the Emissions (1000 metric ton of CO2 equivalent) of 2005 in Qatar to that in Russian Federation?
Make the answer very short. 0. What is the ratio of the Emissions (1000 metric ton of CO2 equivalent) in 2008 in Qatar to that in Russian Federation?
Offer a very short reply. 0. What is the ratio of the Emissions (1000 metric ton of CO2 equivalent) in 1990 in Qatar to that in Saudi Arabia?
Make the answer very short. 0.01. What is the ratio of the Emissions (1000 metric ton of CO2 equivalent) in 2000 in Qatar to that in Saudi Arabia?
Provide a succinct answer. 0.02. What is the ratio of the Emissions (1000 metric ton of CO2 equivalent) in 2005 in Qatar to that in Saudi Arabia?
Make the answer very short. 0.02. What is the ratio of the Emissions (1000 metric ton of CO2 equivalent) in 2008 in Qatar to that in Saudi Arabia?
Your answer should be very brief. 0.02. What is the ratio of the Emissions (1000 metric ton of CO2 equivalent) in 1990 in Qatar to that in Senegal?
Offer a very short reply. 0.01. What is the ratio of the Emissions (1000 metric ton of CO2 equivalent) of 2000 in Qatar to that in Senegal?
Offer a very short reply. 0.02. What is the ratio of the Emissions (1000 metric ton of CO2 equivalent) of 2005 in Qatar to that in Senegal?
Provide a succinct answer. 0.01. What is the ratio of the Emissions (1000 metric ton of CO2 equivalent) in 2008 in Qatar to that in Senegal?
Offer a terse response. 0.01. What is the ratio of the Emissions (1000 metric ton of CO2 equivalent) in 1990 in Qatar to that in Serbia?
Your answer should be very brief. 0.01. What is the ratio of the Emissions (1000 metric ton of CO2 equivalent) of 2000 in Qatar to that in Serbia?
Offer a very short reply. 0.02. What is the ratio of the Emissions (1000 metric ton of CO2 equivalent) in 2005 in Qatar to that in Serbia?
Your response must be concise. 0.02. What is the ratio of the Emissions (1000 metric ton of CO2 equivalent) in 2008 in Qatar to that in Serbia?
Keep it short and to the point. 0.01. What is the ratio of the Emissions (1000 metric ton of CO2 equivalent) of 1990 in Romania to that in Russian Federation?
Your answer should be compact. 0.16. What is the ratio of the Emissions (1000 metric ton of CO2 equivalent) in 2000 in Romania to that in Russian Federation?
Make the answer very short. 0.17. What is the ratio of the Emissions (1000 metric ton of CO2 equivalent) of 2005 in Romania to that in Russian Federation?
Your answer should be compact. 0.19. What is the ratio of the Emissions (1000 metric ton of CO2 equivalent) in 2008 in Romania to that in Russian Federation?
Provide a succinct answer. 0.2. What is the ratio of the Emissions (1000 metric ton of CO2 equivalent) of 1990 in Romania to that in Saudi Arabia?
Offer a terse response. 4.28. What is the ratio of the Emissions (1000 metric ton of CO2 equivalent) in 2000 in Romania to that in Saudi Arabia?
Make the answer very short. 2.17. What is the ratio of the Emissions (1000 metric ton of CO2 equivalent) of 2005 in Romania to that in Saudi Arabia?
Make the answer very short. 2.17. What is the ratio of the Emissions (1000 metric ton of CO2 equivalent) in 2008 in Romania to that in Saudi Arabia?
Give a very brief answer. 2.07. What is the ratio of the Emissions (1000 metric ton of CO2 equivalent) of 1990 in Romania to that in Senegal?
Your answer should be compact. 5.19. What is the ratio of the Emissions (1000 metric ton of CO2 equivalent) of 2000 in Romania to that in Senegal?
Keep it short and to the point. 1.78. What is the ratio of the Emissions (1000 metric ton of CO2 equivalent) of 2005 in Romania to that in Senegal?
Your answer should be compact. 1.83. What is the ratio of the Emissions (1000 metric ton of CO2 equivalent) of 2008 in Romania to that in Senegal?
Provide a succinct answer. 1.36. What is the ratio of the Emissions (1000 metric ton of CO2 equivalent) in 1990 in Romania to that in Serbia?
Provide a succinct answer. 4.06. What is the ratio of the Emissions (1000 metric ton of CO2 equivalent) of 2000 in Romania to that in Serbia?
Provide a succinct answer. 2.38. What is the ratio of the Emissions (1000 metric ton of CO2 equivalent) in 2005 in Romania to that in Serbia?
Provide a succinct answer. 2.23. What is the ratio of the Emissions (1000 metric ton of CO2 equivalent) in 2008 in Romania to that in Serbia?
Your response must be concise. 1.34. What is the ratio of the Emissions (1000 metric ton of CO2 equivalent) in 1990 in Russian Federation to that in Saudi Arabia?
Keep it short and to the point. 27.16. What is the ratio of the Emissions (1000 metric ton of CO2 equivalent) in 2000 in Russian Federation to that in Saudi Arabia?
Keep it short and to the point. 13.12. What is the ratio of the Emissions (1000 metric ton of CO2 equivalent) of 2005 in Russian Federation to that in Saudi Arabia?
Give a very brief answer. 11.26. What is the ratio of the Emissions (1000 metric ton of CO2 equivalent) in 2008 in Russian Federation to that in Saudi Arabia?
Provide a short and direct response. 10.14. What is the ratio of the Emissions (1000 metric ton of CO2 equivalent) of 1990 in Russian Federation to that in Senegal?
Your response must be concise. 32.98. What is the ratio of the Emissions (1000 metric ton of CO2 equivalent) in 2000 in Russian Federation to that in Senegal?
Provide a short and direct response. 10.8. What is the ratio of the Emissions (1000 metric ton of CO2 equivalent) in 2005 in Russian Federation to that in Senegal?
Provide a succinct answer. 9.5. What is the ratio of the Emissions (1000 metric ton of CO2 equivalent) in 2008 in Russian Federation to that in Senegal?
Your response must be concise. 6.69. What is the ratio of the Emissions (1000 metric ton of CO2 equivalent) in 1990 in Russian Federation to that in Serbia?
Provide a short and direct response. 25.79. What is the ratio of the Emissions (1000 metric ton of CO2 equivalent) of 2000 in Russian Federation to that in Serbia?
Keep it short and to the point. 14.43. What is the ratio of the Emissions (1000 metric ton of CO2 equivalent) in 2005 in Russian Federation to that in Serbia?
Your answer should be compact. 11.58. What is the ratio of the Emissions (1000 metric ton of CO2 equivalent) in 2008 in Russian Federation to that in Serbia?
Make the answer very short. 6.6. What is the ratio of the Emissions (1000 metric ton of CO2 equivalent) of 1990 in Saudi Arabia to that in Senegal?
Offer a very short reply. 1.21. What is the ratio of the Emissions (1000 metric ton of CO2 equivalent) in 2000 in Saudi Arabia to that in Senegal?
Provide a short and direct response. 0.82. What is the ratio of the Emissions (1000 metric ton of CO2 equivalent) in 2005 in Saudi Arabia to that in Senegal?
Provide a succinct answer. 0.84. What is the ratio of the Emissions (1000 metric ton of CO2 equivalent) of 2008 in Saudi Arabia to that in Senegal?
Keep it short and to the point. 0.66. What is the ratio of the Emissions (1000 metric ton of CO2 equivalent) in 1990 in Saudi Arabia to that in Serbia?
Your answer should be very brief. 0.95. What is the ratio of the Emissions (1000 metric ton of CO2 equivalent) of 2000 in Saudi Arabia to that in Serbia?
Make the answer very short. 1.1. What is the ratio of the Emissions (1000 metric ton of CO2 equivalent) in 2005 in Saudi Arabia to that in Serbia?
Your answer should be compact. 1.03. What is the ratio of the Emissions (1000 metric ton of CO2 equivalent) of 2008 in Saudi Arabia to that in Serbia?
Your response must be concise. 0.65. What is the ratio of the Emissions (1000 metric ton of CO2 equivalent) in 1990 in Senegal to that in Serbia?
Your response must be concise. 0.78. What is the ratio of the Emissions (1000 metric ton of CO2 equivalent) in 2000 in Senegal to that in Serbia?
Provide a succinct answer. 1.34. What is the ratio of the Emissions (1000 metric ton of CO2 equivalent) in 2005 in Senegal to that in Serbia?
Provide a short and direct response. 1.22. What is the ratio of the Emissions (1000 metric ton of CO2 equivalent) of 2008 in Senegal to that in Serbia?
Your response must be concise. 0.99. What is the difference between the highest and the second highest Emissions (1000 metric ton of CO2 equivalent) of 1990?
Provide a succinct answer. 7.16e+04. What is the difference between the highest and the second highest Emissions (1000 metric ton of CO2 equivalent) of 2000?
Give a very brief answer. 3.01e+04. What is the difference between the highest and the second highest Emissions (1000 metric ton of CO2 equivalent) of 2005?
Give a very brief answer. 2.73e+04. What is the difference between the highest and the second highest Emissions (1000 metric ton of CO2 equivalent) in 2008?
Provide a succinct answer. 2.47e+04. What is the difference between the highest and the lowest Emissions (1000 metric ton of CO2 equivalent) in 1990?
Give a very brief answer. 8.49e+04. What is the difference between the highest and the lowest Emissions (1000 metric ton of CO2 equivalent) of 2000?
Keep it short and to the point. 3.60e+04. What is the difference between the highest and the lowest Emissions (1000 metric ton of CO2 equivalent) in 2005?
Offer a terse response. 3.37e+04. What is the difference between the highest and the lowest Emissions (1000 metric ton of CO2 equivalent) in 2008?
Ensure brevity in your answer.  3.10e+04. 